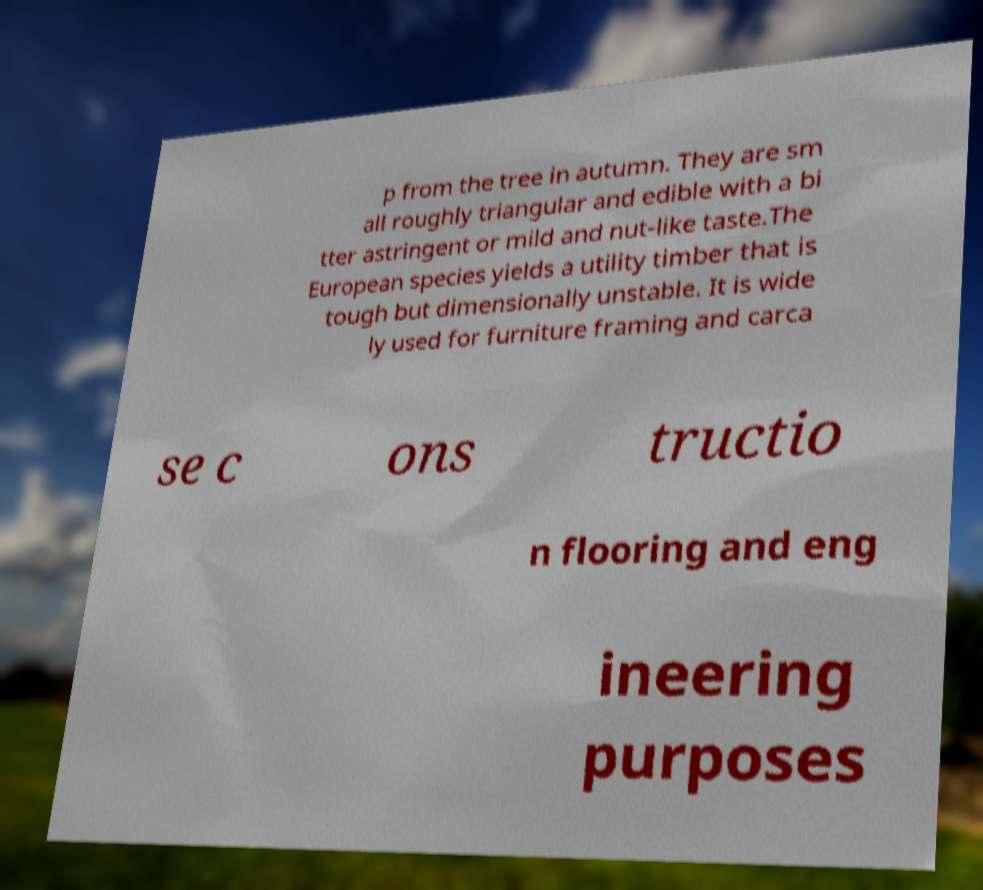Please read and relay the text visible in this image. What does it say? p from the tree in autumn. They are sm all roughly triangular and edible with a bi tter astringent or mild and nut-like taste.The European species yields a utility timber that is tough but dimensionally unstable. It is wide ly used for furniture framing and carca se c ons tructio n flooring and eng ineering purposes 